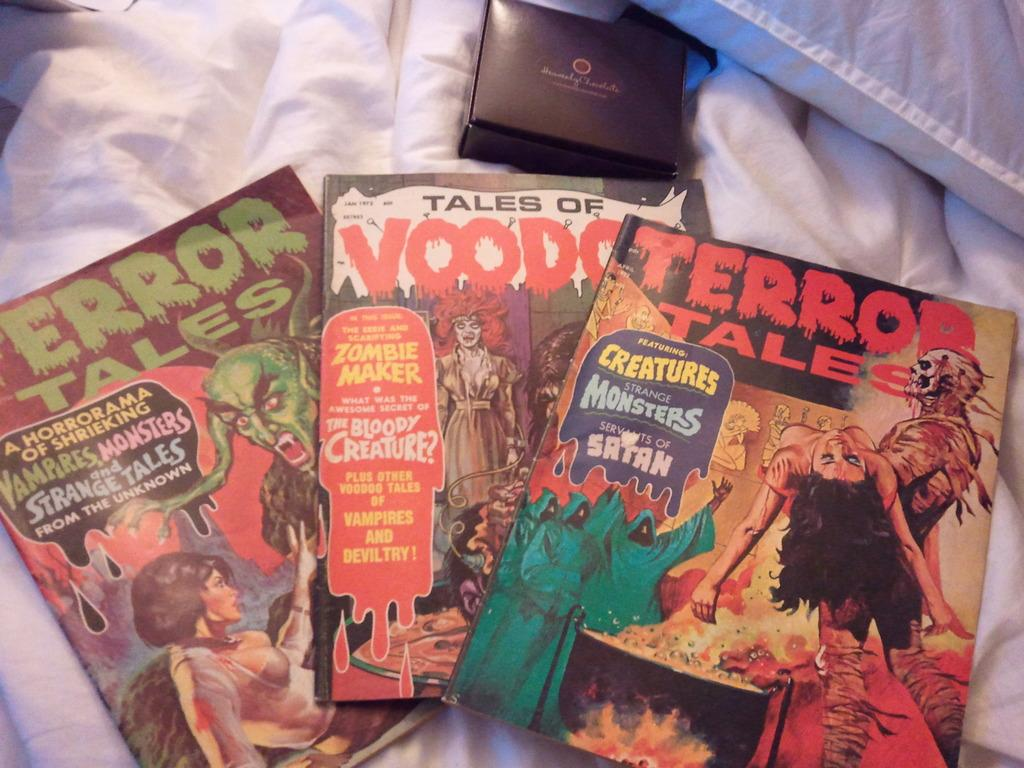Provide a one-sentence caption for the provided image. A bunch of horror comics including Terror Tales and Tales of Voodoo. 